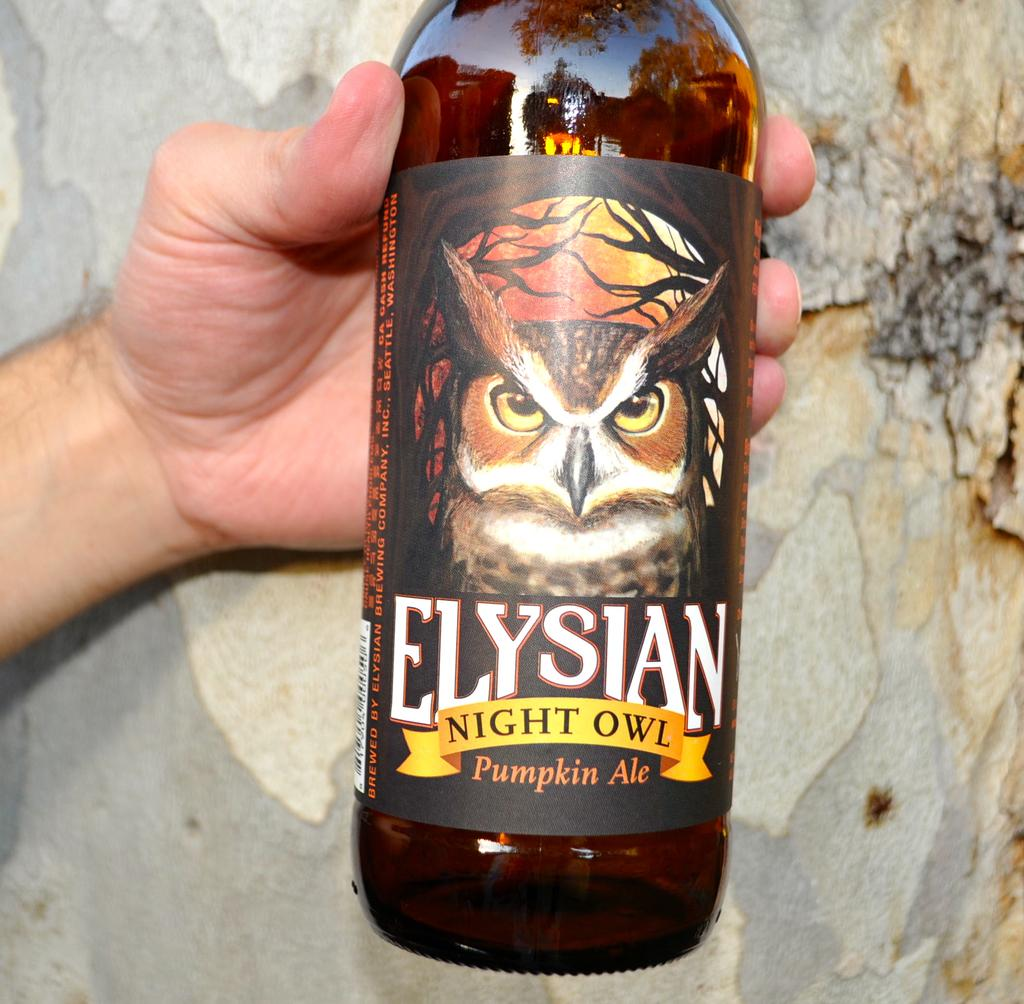<image>
Relay a brief, clear account of the picture shown. A man is holding a bottle of Elysian Night Owl pumpkin ale. 